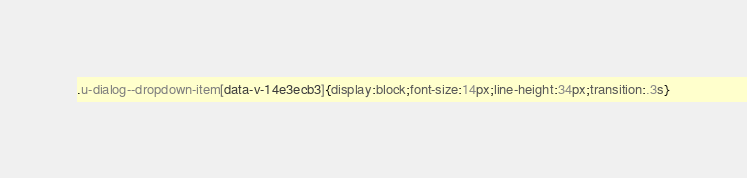Convert code to text. <code><loc_0><loc_0><loc_500><loc_500><_CSS_>.u-dialog--dropdown-item[data-v-14e3ecb3]{display:block;font-size:14px;line-height:34px;transition:.3s}
</code> 